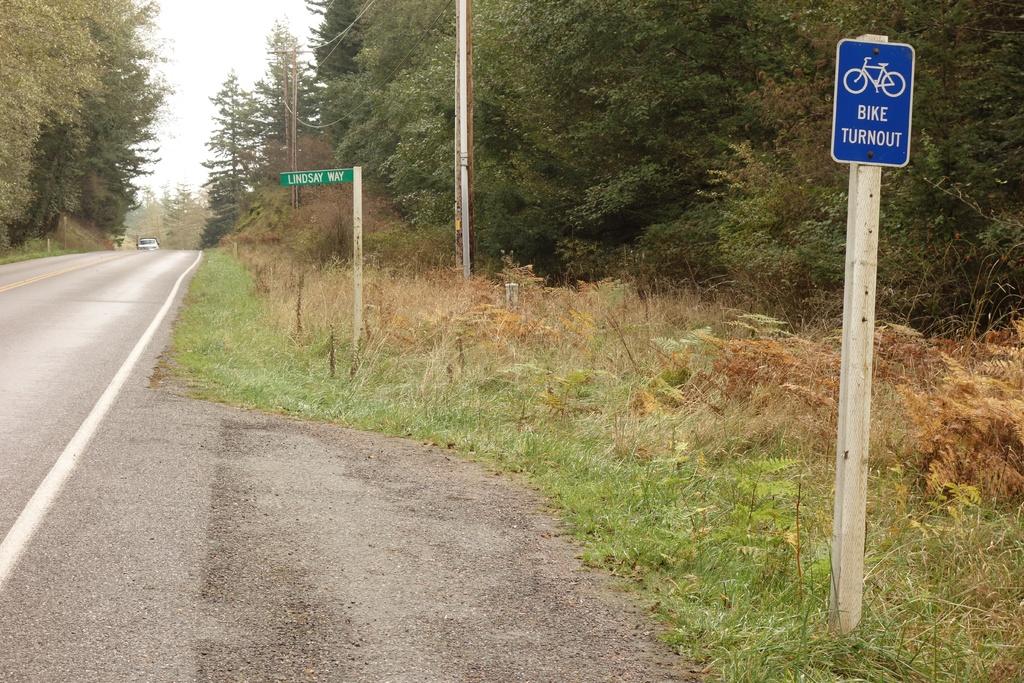Which street is listed on the green sign?
Ensure brevity in your answer.  Lindsay way. What kind of turnout is going on?
Your answer should be compact. Bike. 